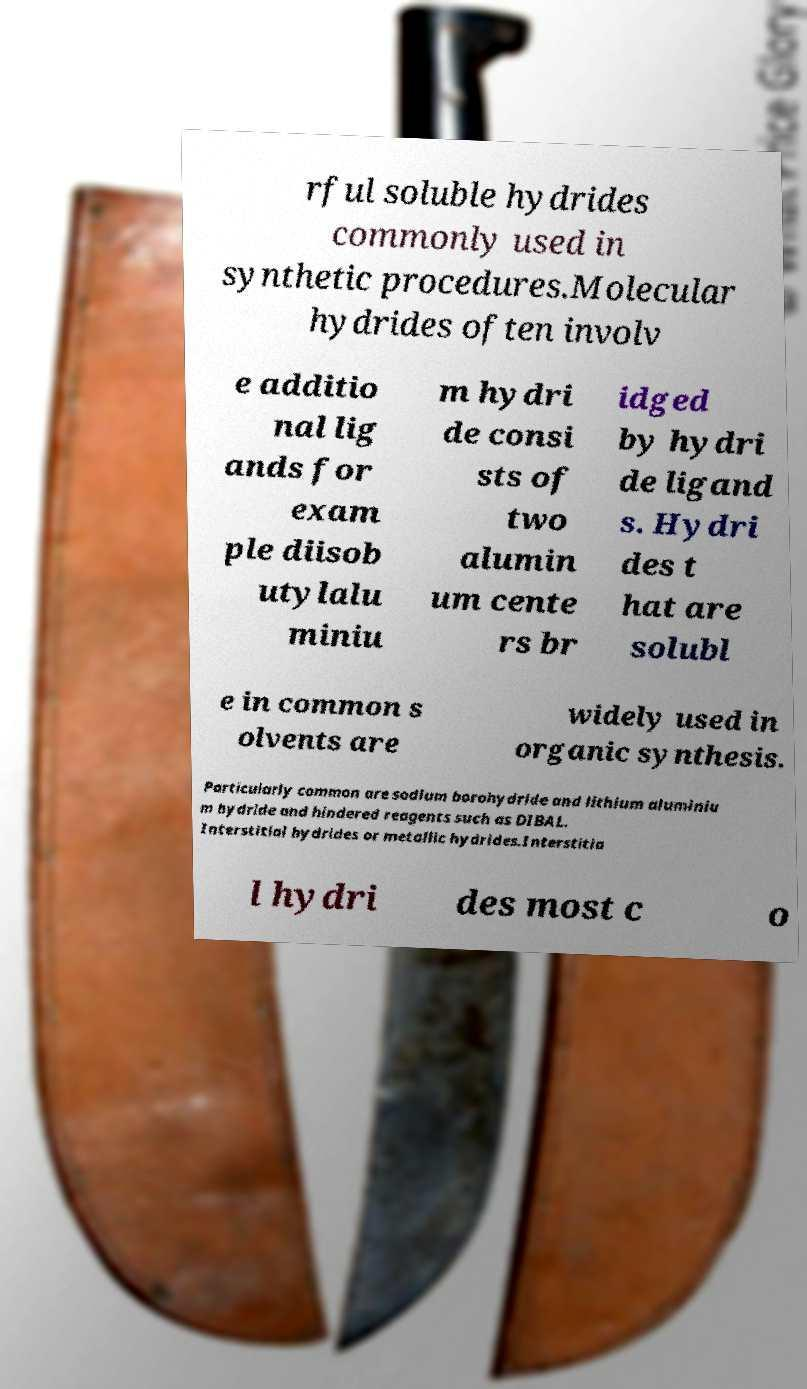Can you accurately transcribe the text from the provided image for me? rful soluble hydrides commonly used in synthetic procedures.Molecular hydrides often involv e additio nal lig ands for exam ple diisob utylalu miniu m hydri de consi sts of two alumin um cente rs br idged by hydri de ligand s. Hydri des t hat are solubl e in common s olvents are widely used in organic synthesis. Particularly common are sodium borohydride and lithium aluminiu m hydride and hindered reagents such as DIBAL. Interstitial hydrides or metallic hydrides.Interstitia l hydri des most c o 